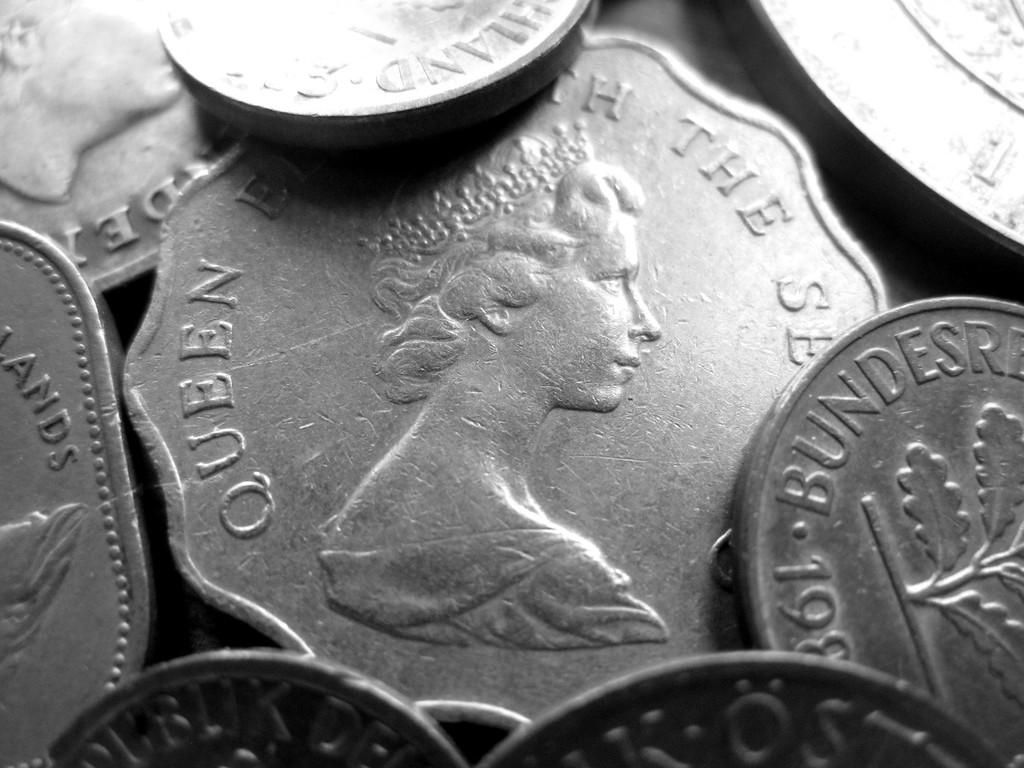<image>
Provide a brief description of the given image. A pile of silver coins, one of which has a picture of a queen on it. 